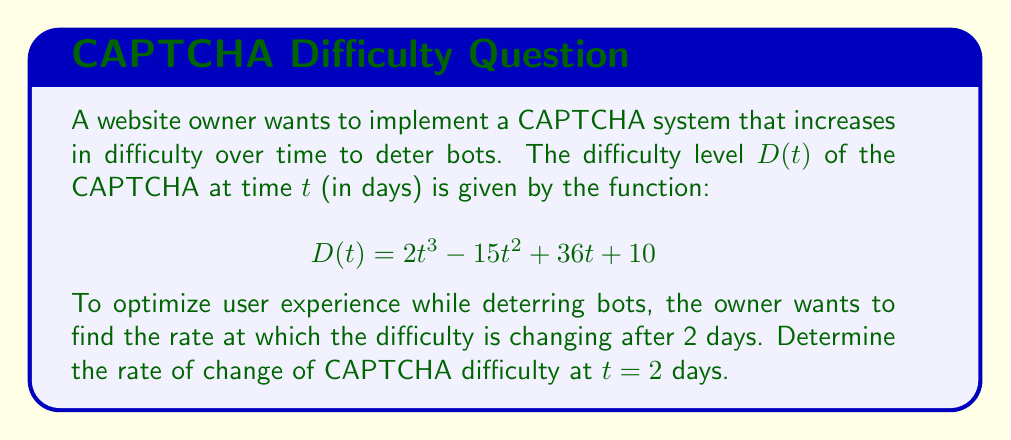Show me your answer to this math problem. To find the rate of change of CAPTCHA difficulty at $t = 2$ days, we need to calculate the derivative of $D(t)$ and then evaluate it at $t = 2$.

Step 1: Calculate the derivative of $D(t)$
$$D(t) = 2t^3 - 15t^2 + 36t + 10$$
$$D'(t) = 6t^2 - 30t + 36$$

Step 2: Evaluate $D'(t)$ at $t = 2$
$$D'(2) = 6(2)^2 - 30(2) + 36$$
$$D'(2) = 6(4) - 60 + 36$$
$$D'(2) = 24 - 60 + 36$$
$$D'(2) = 0$$

Therefore, the rate of change of CAPTCHA difficulty at $t = 2$ days is 0 units per day.
Answer: 0 units/day 